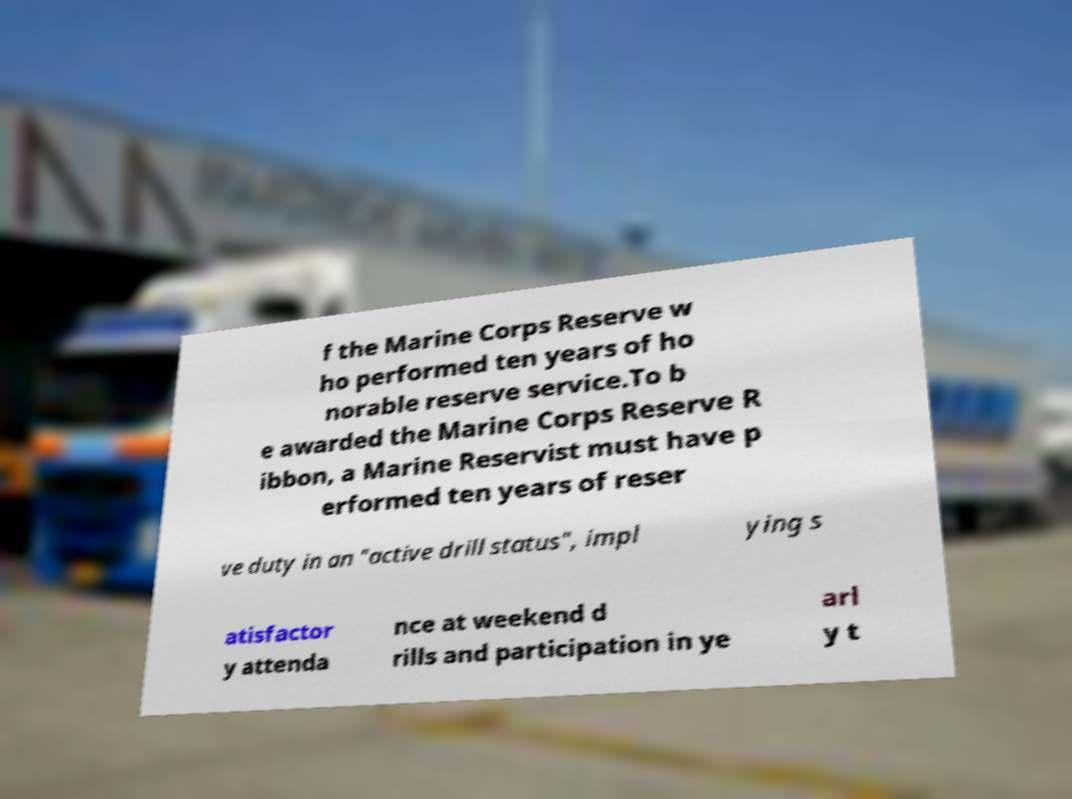There's text embedded in this image that I need extracted. Can you transcribe it verbatim? f the Marine Corps Reserve w ho performed ten years of ho norable reserve service.To b e awarded the Marine Corps Reserve R ibbon, a Marine Reservist must have p erformed ten years of reser ve duty in an "active drill status", impl ying s atisfactor y attenda nce at weekend d rills and participation in ye arl y t 